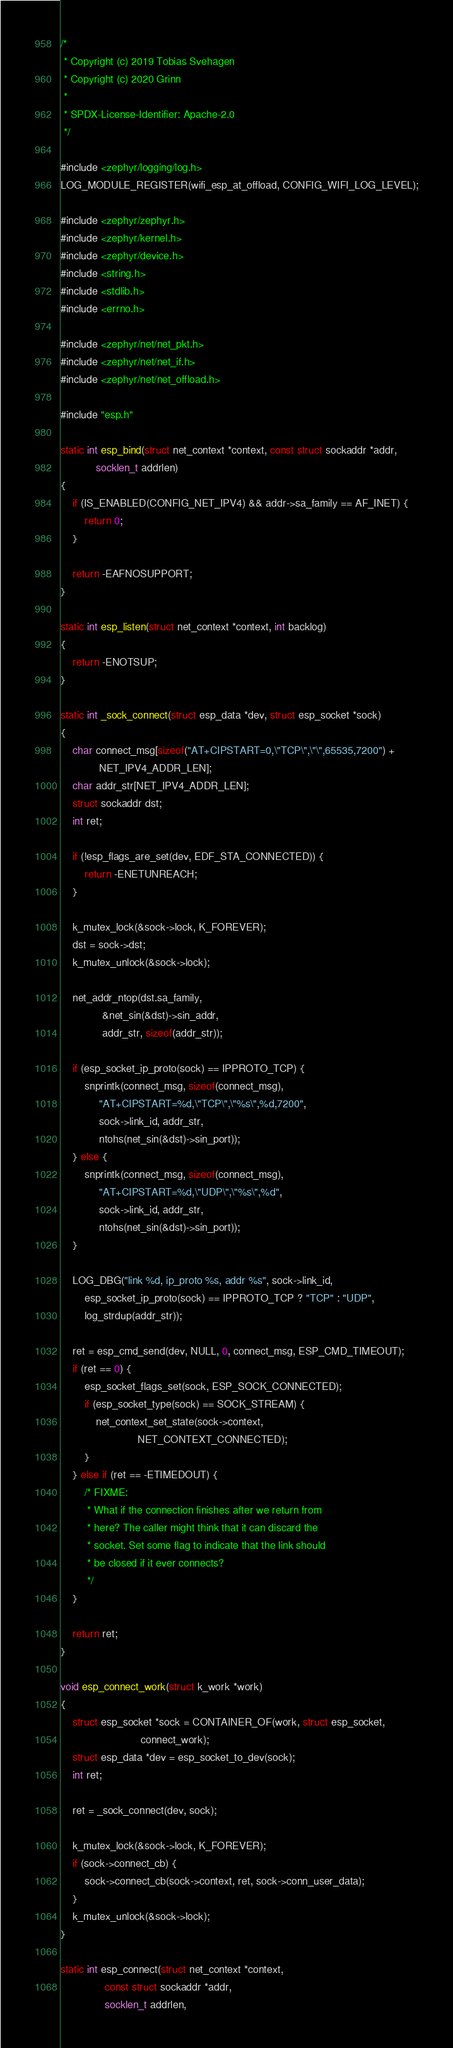<code> <loc_0><loc_0><loc_500><loc_500><_C_>/*
 * Copyright (c) 2019 Tobias Svehagen
 * Copyright (c) 2020 Grinn
 *
 * SPDX-License-Identifier: Apache-2.0
 */

#include <zephyr/logging/log.h>
LOG_MODULE_REGISTER(wifi_esp_at_offload, CONFIG_WIFI_LOG_LEVEL);

#include <zephyr/zephyr.h>
#include <zephyr/kernel.h>
#include <zephyr/device.h>
#include <string.h>
#include <stdlib.h>
#include <errno.h>

#include <zephyr/net/net_pkt.h>
#include <zephyr/net/net_if.h>
#include <zephyr/net/net_offload.h>

#include "esp.h"

static int esp_bind(struct net_context *context, const struct sockaddr *addr,
		    socklen_t addrlen)
{
	if (IS_ENABLED(CONFIG_NET_IPV4) && addr->sa_family == AF_INET) {
		return 0;
	}

	return -EAFNOSUPPORT;
}

static int esp_listen(struct net_context *context, int backlog)
{
	return -ENOTSUP;
}

static int _sock_connect(struct esp_data *dev, struct esp_socket *sock)
{
	char connect_msg[sizeof("AT+CIPSTART=0,\"TCP\",\"\",65535,7200") +
			 NET_IPV4_ADDR_LEN];
	char addr_str[NET_IPV4_ADDR_LEN];
	struct sockaddr dst;
	int ret;

	if (!esp_flags_are_set(dev, EDF_STA_CONNECTED)) {
		return -ENETUNREACH;
	}

	k_mutex_lock(&sock->lock, K_FOREVER);
	dst = sock->dst;
	k_mutex_unlock(&sock->lock);

	net_addr_ntop(dst.sa_family,
		      &net_sin(&dst)->sin_addr,
		      addr_str, sizeof(addr_str));

	if (esp_socket_ip_proto(sock) == IPPROTO_TCP) {
		snprintk(connect_msg, sizeof(connect_msg),
			 "AT+CIPSTART=%d,\"TCP\",\"%s\",%d,7200",
			 sock->link_id, addr_str,
			 ntohs(net_sin(&dst)->sin_port));
	} else {
		snprintk(connect_msg, sizeof(connect_msg),
			 "AT+CIPSTART=%d,\"UDP\",\"%s\",%d",
			 sock->link_id, addr_str,
			 ntohs(net_sin(&dst)->sin_port));
	}

	LOG_DBG("link %d, ip_proto %s, addr %s", sock->link_id,
		esp_socket_ip_proto(sock) == IPPROTO_TCP ? "TCP" : "UDP",
		log_strdup(addr_str));

	ret = esp_cmd_send(dev, NULL, 0, connect_msg, ESP_CMD_TIMEOUT);
	if (ret == 0) {
		esp_socket_flags_set(sock, ESP_SOCK_CONNECTED);
		if (esp_socket_type(sock) == SOCK_STREAM) {
			net_context_set_state(sock->context,
					      NET_CONTEXT_CONNECTED);
		}
	} else if (ret == -ETIMEDOUT) {
		/* FIXME:
		 * What if the connection finishes after we return from
		 * here? The caller might think that it can discard the
		 * socket. Set some flag to indicate that the link should
		 * be closed if it ever connects?
		 */
	}

	return ret;
}

void esp_connect_work(struct k_work *work)
{
	struct esp_socket *sock = CONTAINER_OF(work, struct esp_socket,
					       connect_work);
	struct esp_data *dev = esp_socket_to_dev(sock);
	int ret;

	ret = _sock_connect(dev, sock);

	k_mutex_lock(&sock->lock, K_FOREVER);
	if (sock->connect_cb) {
		sock->connect_cb(sock->context, ret, sock->conn_user_data);
	}
	k_mutex_unlock(&sock->lock);
}

static int esp_connect(struct net_context *context,
		       const struct sockaddr *addr,
		       socklen_t addrlen,</code> 